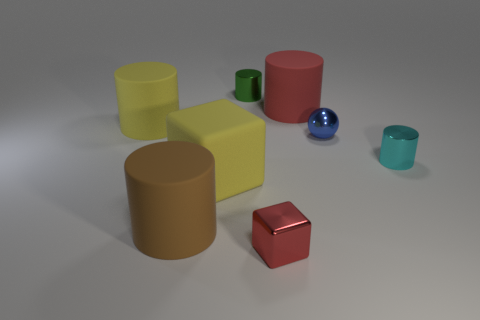Subtract all brown cylinders. How many cylinders are left? 4 Subtract all cyan cylinders. How many cylinders are left? 4 Subtract all yellow cylinders. Subtract all green spheres. How many cylinders are left? 4 Add 2 green shiny cubes. How many objects exist? 10 Subtract all blocks. How many objects are left? 6 Add 3 green objects. How many green objects are left? 4 Add 7 blue things. How many blue things exist? 8 Subtract 1 blue spheres. How many objects are left? 7 Subtract all cyan shiny objects. Subtract all big red rubber cylinders. How many objects are left? 6 